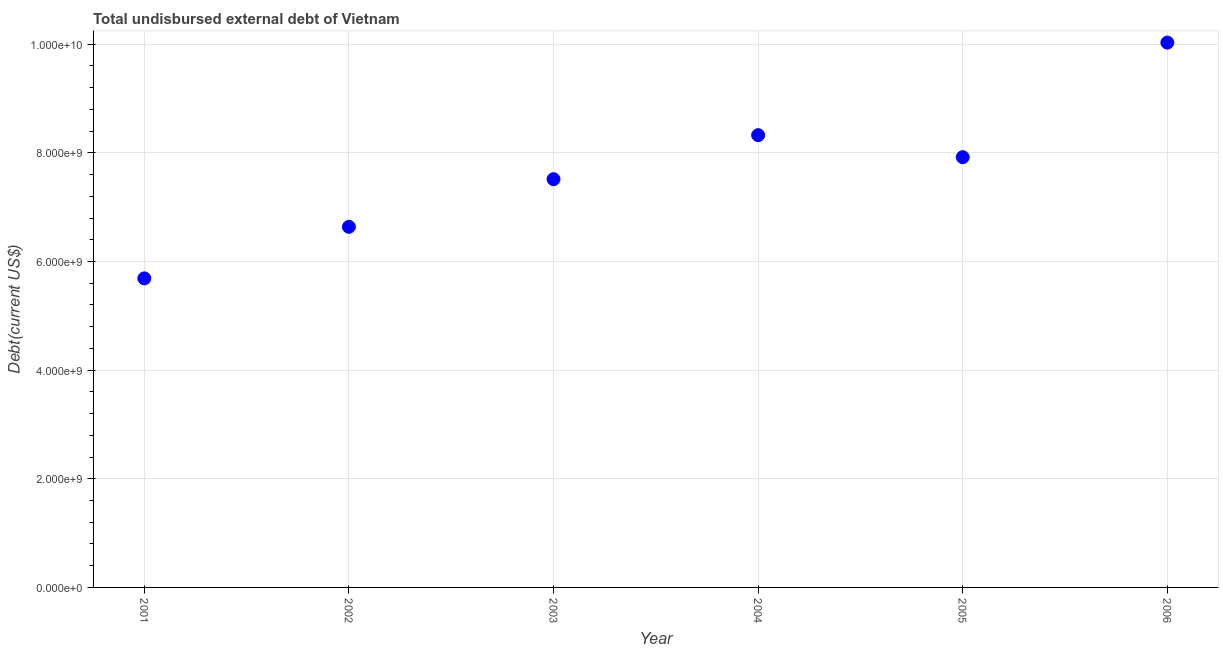What is the total debt in 2005?
Provide a succinct answer. 7.92e+09. Across all years, what is the maximum total debt?
Your response must be concise. 1.00e+1. Across all years, what is the minimum total debt?
Your answer should be compact. 5.69e+09. What is the sum of the total debt?
Make the answer very short. 4.61e+1. What is the difference between the total debt in 2003 and 2005?
Your answer should be compact. -4.05e+08. What is the average total debt per year?
Your response must be concise. 7.69e+09. What is the median total debt?
Your answer should be very brief. 7.72e+09. In how many years, is the total debt greater than 2400000000 US$?
Give a very brief answer. 6. What is the ratio of the total debt in 2002 to that in 2003?
Provide a short and direct response. 0.88. Is the total debt in 2004 less than that in 2006?
Keep it short and to the point. Yes. Is the difference between the total debt in 2001 and 2002 greater than the difference between any two years?
Offer a very short reply. No. What is the difference between the highest and the second highest total debt?
Offer a very short reply. 1.70e+09. Is the sum of the total debt in 2005 and 2006 greater than the maximum total debt across all years?
Your answer should be compact. Yes. What is the difference between the highest and the lowest total debt?
Offer a very short reply. 4.34e+09. In how many years, is the total debt greater than the average total debt taken over all years?
Keep it short and to the point. 3. Does the total debt monotonically increase over the years?
Your response must be concise. No. Are the values on the major ticks of Y-axis written in scientific E-notation?
Ensure brevity in your answer.  Yes. Does the graph contain grids?
Make the answer very short. Yes. What is the title of the graph?
Give a very brief answer. Total undisbursed external debt of Vietnam. What is the label or title of the X-axis?
Provide a short and direct response. Year. What is the label or title of the Y-axis?
Offer a very short reply. Debt(current US$). What is the Debt(current US$) in 2001?
Provide a short and direct response. 5.69e+09. What is the Debt(current US$) in 2002?
Ensure brevity in your answer.  6.64e+09. What is the Debt(current US$) in 2003?
Keep it short and to the point. 7.52e+09. What is the Debt(current US$) in 2004?
Your response must be concise. 8.33e+09. What is the Debt(current US$) in 2005?
Your response must be concise. 7.92e+09. What is the Debt(current US$) in 2006?
Offer a terse response. 1.00e+1. What is the difference between the Debt(current US$) in 2001 and 2002?
Ensure brevity in your answer.  -9.49e+08. What is the difference between the Debt(current US$) in 2001 and 2003?
Your answer should be compact. -1.83e+09. What is the difference between the Debt(current US$) in 2001 and 2004?
Offer a very short reply. -2.64e+09. What is the difference between the Debt(current US$) in 2001 and 2005?
Give a very brief answer. -2.23e+09. What is the difference between the Debt(current US$) in 2001 and 2006?
Your response must be concise. -4.34e+09. What is the difference between the Debt(current US$) in 2002 and 2003?
Your answer should be compact. -8.77e+08. What is the difference between the Debt(current US$) in 2002 and 2004?
Provide a succinct answer. -1.69e+09. What is the difference between the Debt(current US$) in 2002 and 2005?
Your response must be concise. -1.28e+09. What is the difference between the Debt(current US$) in 2002 and 2006?
Make the answer very short. -3.39e+09. What is the difference between the Debt(current US$) in 2003 and 2004?
Keep it short and to the point. -8.11e+08. What is the difference between the Debt(current US$) in 2003 and 2005?
Offer a terse response. -4.05e+08. What is the difference between the Debt(current US$) in 2003 and 2006?
Your response must be concise. -2.51e+09. What is the difference between the Debt(current US$) in 2004 and 2005?
Keep it short and to the point. 4.06e+08. What is the difference between the Debt(current US$) in 2004 and 2006?
Your response must be concise. -1.70e+09. What is the difference between the Debt(current US$) in 2005 and 2006?
Ensure brevity in your answer.  -2.11e+09. What is the ratio of the Debt(current US$) in 2001 to that in 2002?
Offer a very short reply. 0.86. What is the ratio of the Debt(current US$) in 2001 to that in 2003?
Offer a very short reply. 0.76. What is the ratio of the Debt(current US$) in 2001 to that in 2004?
Make the answer very short. 0.68. What is the ratio of the Debt(current US$) in 2001 to that in 2005?
Offer a terse response. 0.72. What is the ratio of the Debt(current US$) in 2001 to that in 2006?
Offer a very short reply. 0.57. What is the ratio of the Debt(current US$) in 2002 to that in 2003?
Make the answer very short. 0.88. What is the ratio of the Debt(current US$) in 2002 to that in 2004?
Offer a very short reply. 0.8. What is the ratio of the Debt(current US$) in 2002 to that in 2005?
Keep it short and to the point. 0.84. What is the ratio of the Debt(current US$) in 2002 to that in 2006?
Ensure brevity in your answer.  0.66. What is the ratio of the Debt(current US$) in 2003 to that in 2004?
Your answer should be compact. 0.9. What is the ratio of the Debt(current US$) in 2003 to that in 2005?
Offer a very short reply. 0.95. What is the ratio of the Debt(current US$) in 2003 to that in 2006?
Make the answer very short. 0.75. What is the ratio of the Debt(current US$) in 2004 to that in 2005?
Your answer should be compact. 1.05. What is the ratio of the Debt(current US$) in 2004 to that in 2006?
Provide a succinct answer. 0.83. What is the ratio of the Debt(current US$) in 2005 to that in 2006?
Keep it short and to the point. 0.79. 